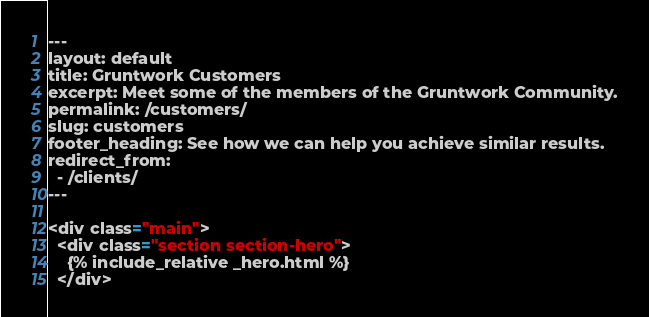Convert code to text. <code><loc_0><loc_0><loc_500><loc_500><_HTML_>---
layout: default
title: Gruntwork Customers
excerpt: Meet some of the members of the Gruntwork Community.
permalink: /customers/
slug: customers
footer_heading: See how we can help you achieve similar results.
redirect_from:
  - /clients/
---

<div class="main">
  <div class="section section-hero">
    {% include_relative _hero.html %}
  </div></code> 